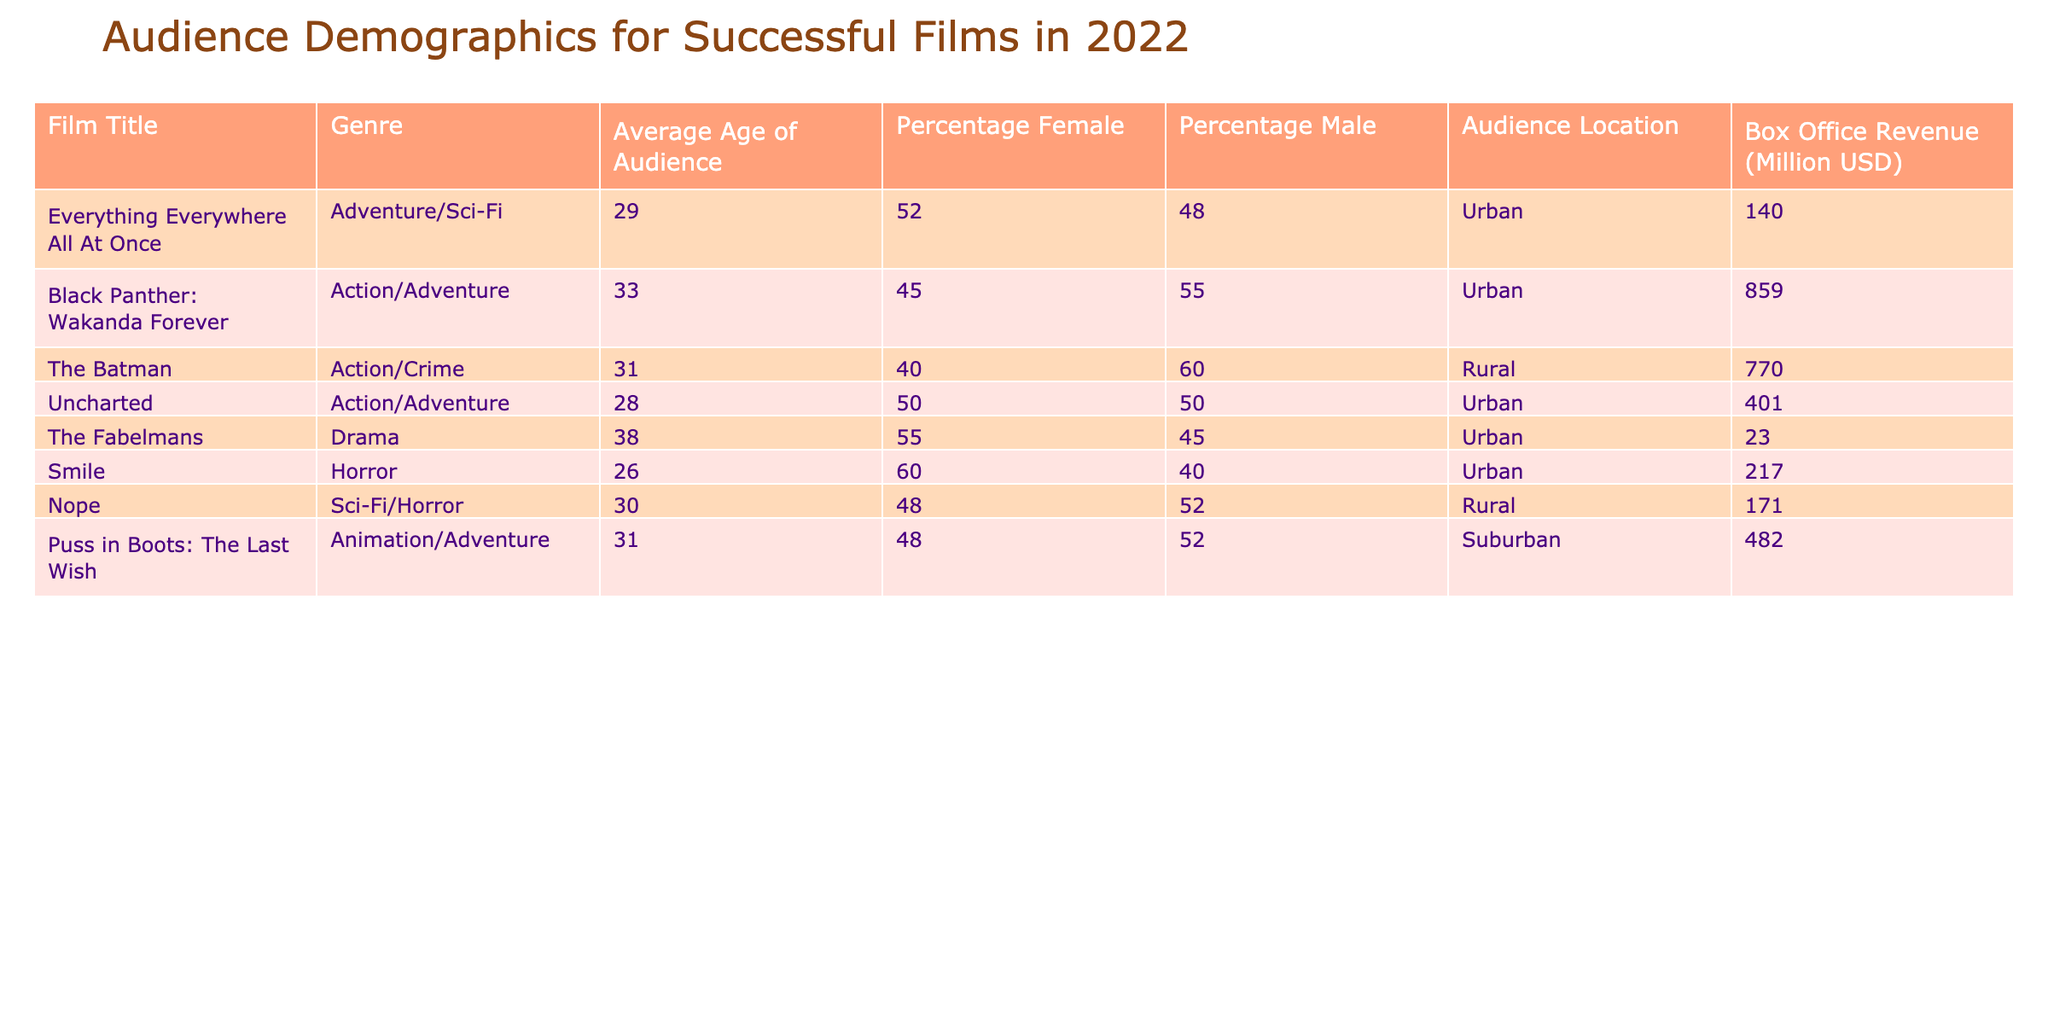What's the average age of the audience for "Nope"? The table states the average age of the audience for "Nope" is 30 years old. This information can be found directly in the corresponding row for the film.
Answer: 30 Which film has the highest percentage of female audience members? Looking at the percentage of female audience members for each film, "Smile" has the highest percentage at 60%. This can be identified by scanning the percentage values and comparing them.
Answer: 60 Is the audience for "The Fabelmans" primarily male? The percentage of male audience members for "The Fabelmans" is 45%, while the percentage of female audience members is 55%. Since the majority (more than 50%) are female, the audience is not primarily male.
Answer: No What is the total box office revenue for films with an average audience age below 30? The films with an average audience age below 30 are "Everything Everywhere All At Once" (140), "Uncharted" (401), and "Smile" (217). Adding these values together gives 140 + 401 + 217 = 758 million USD.
Answer: 758 Does "Black Panther: Wakanda Forever" have a higher box office revenue than "The Batman"? "Black Panther: Wakanda Forever" has a box office revenue of 859 million USD, while "The Batman" has 770 million USD. Since 859 is greater than 770, the statement is true.
Answer: Yes What is the average male audience percentage for films with box office revenue exceeding 400 million USD? The films with box office revenue exceeding 400 million USD are "Black Panther: Wakanda Forever" (55), "The Batman" (60), and "Puss in Boots: The Last Wish" (52). To find the average: (55 + 60 + 52) / 3 = 55.67, which rounds to approximately 56%.
Answer: 56 Which genre has the oldest average audience age? The data shows that "The Fabelmans," which falls under the Drama genre, has an average audience age of 38, making it the oldest audience age compared to other films. The ages for other genres are lower when examined.
Answer: Drama Which film has the highest box office revenue, and what is that revenue? Scanning the table, "Black Panther: Wakanda Forever" has the highest box office revenue at 859 million USD. This can be seen under the corresponding column and row.
Answer: 859 